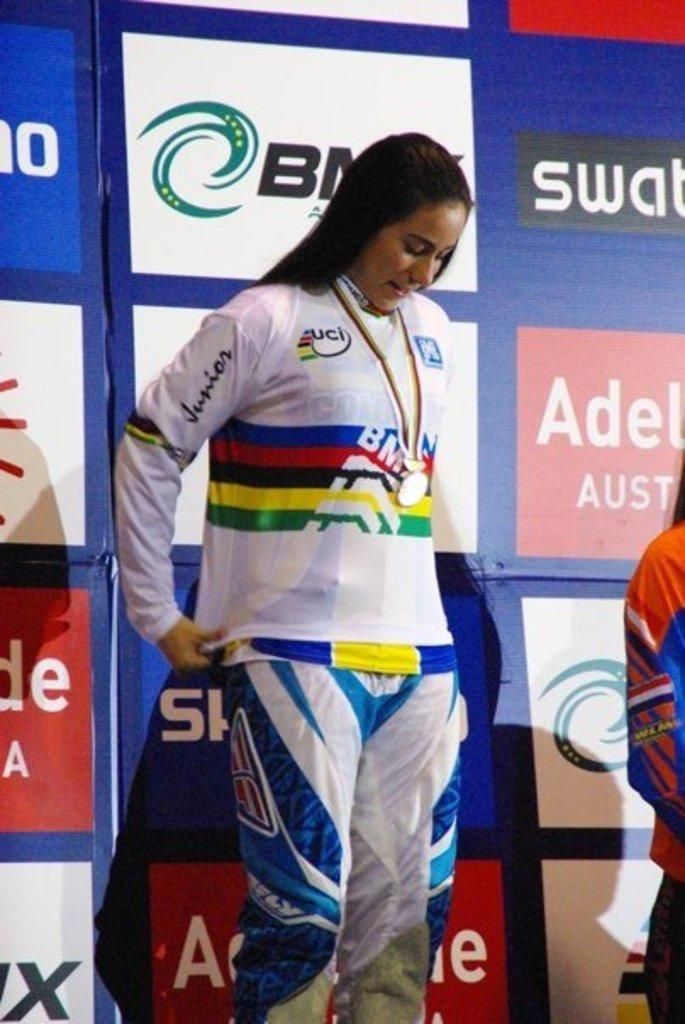<image>
Summarize the visual content of the image. A young woman wears a BMX racing outfit while on stage in front of various advertisements. 